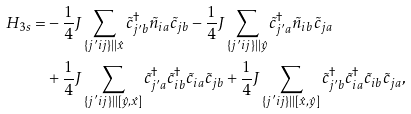<formula> <loc_0><loc_0><loc_500><loc_500>H _ { 3 s } = & - \frac { 1 } { 4 } J \sum _ { \substack { \{ j ^ { \prime } i j \} | | \hat { x } } } \tilde { c } ^ { \dag } _ { j ^ { \prime } b } \tilde { n } _ { i a } \tilde { c } _ { j b } - \frac { 1 } { 4 } J \sum _ { \substack { \{ j ^ { \prime } i j \} | | \hat { y } } } \tilde { c } ^ { \dag } _ { j ^ { \prime } a } \tilde { n } _ { i b } \tilde { c } _ { j a } \\ & + \frac { 1 } { 4 } J \sum _ { \substack { \{ j ^ { \prime } i j \} | | [ \hat { y } , \hat { x } ] } } \tilde { c } ^ { \dag } _ { j ^ { \prime } a } \tilde { c } ^ { \dag } _ { i b } \tilde { c } _ { i a } \tilde { c } _ { j b } + \frac { 1 } { 4 } J \sum _ { \substack { \{ j ^ { \prime } i j \} | | [ \hat { x } , \hat { y } ] } } \tilde { c } ^ { \dag } _ { j ^ { \prime } b } \tilde { c } ^ { \dag } _ { i a } \tilde { c } _ { i b } \tilde { c } _ { j a } ,</formula> 